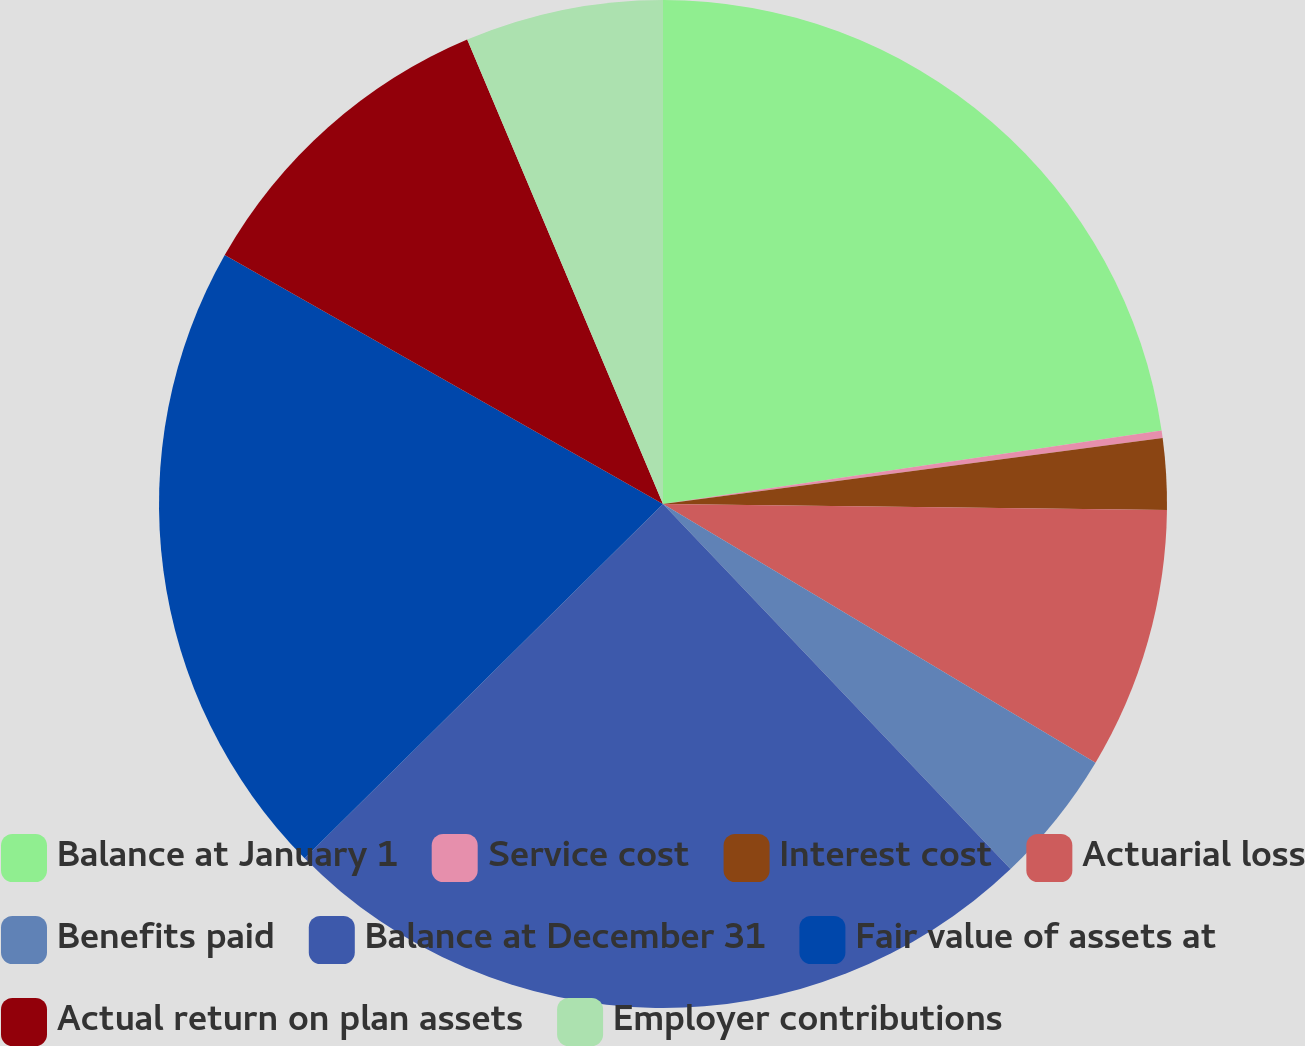<chart> <loc_0><loc_0><loc_500><loc_500><pie_chart><fcel>Balance at January 1<fcel>Service cost<fcel>Interest cost<fcel>Actuarial loss<fcel>Benefits paid<fcel>Balance at December 31<fcel>Fair value of assets at<fcel>Actual return on plan assets<fcel>Employer contributions<nl><fcel>22.67%<fcel>0.24%<fcel>2.28%<fcel>8.39%<fcel>4.31%<fcel>24.7%<fcel>20.63%<fcel>10.43%<fcel>6.35%<nl></chart> 